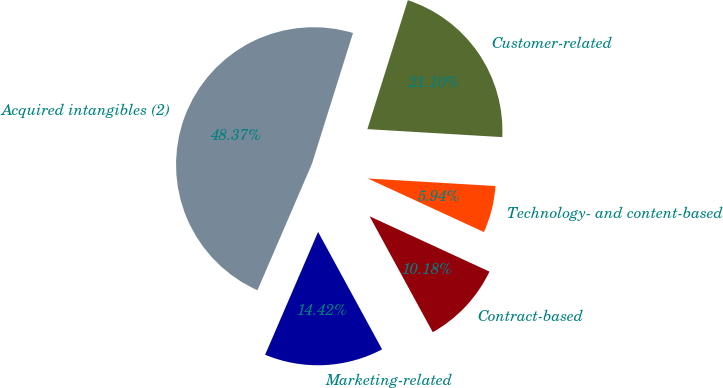Convert chart. <chart><loc_0><loc_0><loc_500><loc_500><pie_chart><fcel>Marketing-related<fcel>Contract-based<fcel>Technology- and content-based<fcel>Customer-related<fcel>Acquired intangibles (2)<nl><fcel>14.42%<fcel>10.18%<fcel>5.94%<fcel>21.1%<fcel>48.37%<nl></chart> 